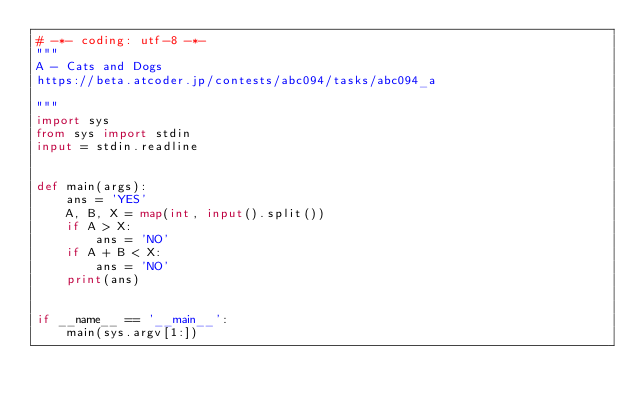<code> <loc_0><loc_0><loc_500><loc_500><_Python_># -*- coding: utf-8 -*-
"""
A - Cats and Dogs
https://beta.atcoder.jp/contests/abc094/tasks/abc094_a

"""
import sys
from sys import stdin
input = stdin.readline


def main(args):
    ans = 'YES'
    A, B, X = map(int, input().split())
    if A > X:
        ans = 'NO'
    if A + B < X:
        ans = 'NO'
    print(ans)


if __name__ == '__main__':
    main(sys.argv[1:])
    
</code> 